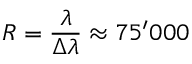Convert formula to latex. <formula><loc_0><loc_0><loc_500><loc_500>R = \frac { \lambda } { \lambda } \approx 7 5 ^ { \prime } 0 0 0</formula> 